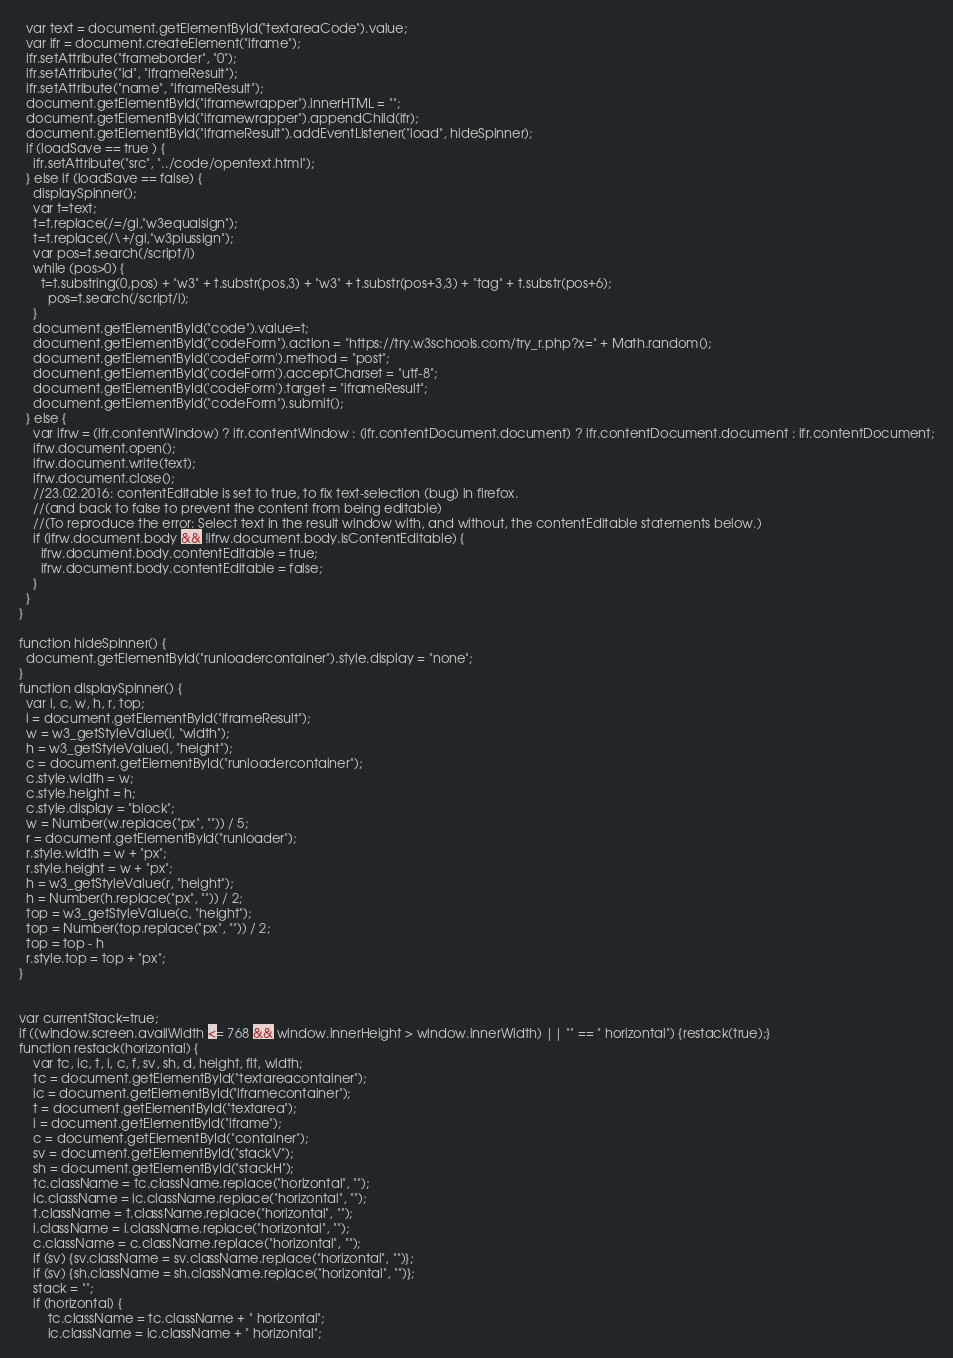<code> <loc_0><loc_0><loc_500><loc_500><_HTML_>  var text = document.getElementById("textareaCode").value;
  var ifr = document.createElement("iframe");
  ifr.setAttribute("frameborder", "0");
  ifr.setAttribute("id", "iframeResult");
  ifr.setAttribute("name", "iframeResult");  
  document.getElementById("iframewrapper").innerHTML = "";
  document.getElementById("iframewrapper").appendChild(ifr);
  document.getElementById("iframeResult").addEventListener("load", hideSpinner);
  if (loadSave == true ) {
    ifr.setAttribute("src", "../code/opentext.html");
  } else if (loadSave == false) {
    displaySpinner();
    var t=text;
    t=t.replace(/=/gi,"w3equalsign");
    t=t.replace(/\+/gi,"w3plussign");    
    var pos=t.search(/script/i)
    while (pos>0) {
      t=t.substring(0,pos) + "w3" + t.substr(pos,3) + "w3" + t.substr(pos+3,3) + "tag" + t.substr(pos+6);
	    pos=t.search(/script/i);
    }
    document.getElementById("code").value=t;
    document.getElementById("codeForm").action = "https://try.w3schools.com/try_r.php?x=" + Math.random();
    document.getElementById('codeForm').method = "post";
    document.getElementById('codeForm').acceptCharset = "utf-8";
    document.getElementById('codeForm').target = "iframeResult";
    document.getElementById("codeForm").submit();
  } else {
    var ifrw = (ifr.contentWindow) ? ifr.contentWindow : (ifr.contentDocument.document) ? ifr.contentDocument.document : ifr.contentDocument;
    ifrw.document.open();
    ifrw.document.write(text);  
    ifrw.document.close();
    //23.02.2016: contentEditable is set to true, to fix text-selection (bug) in firefox.
    //(and back to false to prevent the content from being editable)
    //(To reproduce the error: Select text in the result window with, and without, the contentEditable statements below.)  
    if (ifrw.document.body && !ifrw.document.body.isContentEditable) {
      ifrw.document.body.contentEditable = true;
      ifrw.document.body.contentEditable = false;
    }
  }
}

function hideSpinner() {
  document.getElementById("runloadercontainer").style.display = "none";
}
function displaySpinner() {
  var i, c, w, h, r, top;
  i = document.getElementById("iframeResult");
  w = w3_getStyleValue(i, "width");
  h = w3_getStyleValue(i, "height");
  c = document.getElementById("runloadercontainer");
  c.style.width = w;
  c.style.height = h;
  c.style.display = "block";
  w = Number(w.replace("px", "")) / 5;
  r = document.getElementById("runloader");
  r.style.width = w + "px";
  r.style.height = w + "px";
  h = w3_getStyleValue(r, "height");
  h = Number(h.replace("px", "")) / 2;
  top = w3_getStyleValue(c, "height");
  top = Number(top.replace("px", "")) / 2;
  top = top - h
  r.style.top = top + "px";
}


var currentStack=true;
if ((window.screen.availWidth <= 768 && window.innerHeight > window.innerWidth) || "" == " horizontal") {restack(true);}
function restack(horizontal) {
    var tc, ic, t, i, c, f, sv, sh, d, height, flt, width;
    tc = document.getElementById("textareacontainer");
    ic = document.getElementById("iframecontainer");
    t = document.getElementById("textarea");
    i = document.getElementById("iframe");
    c = document.getElementById("container");    
    sv = document.getElementById("stackV");
    sh = document.getElementById("stackH");
    tc.className = tc.className.replace("horizontal", "");
    ic.className = ic.className.replace("horizontal", "");        
    t.className = t.className.replace("horizontal", "");        
    i.className = i.className.replace("horizontal", "");        
    c.className = c.className.replace("horizontal", "");                        
    if (sv) {sv.className = sv.className.replace("horizontal", "")};
    if (sv) {sh.className = sh.className.replace("horizontal", "")};
    stack = "";
    if (horizontal) {
        tc.className = tc.className + " horizontal";
        ic.className = ic.className + " horizontal";        </code> 